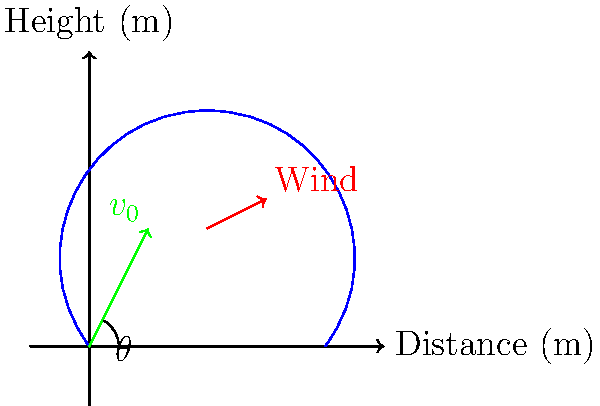As a quarterback, you need to calculate the optimal trajectory for a 40-meter pass. The wind is blowing at 5 m/s at a 30-degree angle to the direction of the pass. Given that the optimal launch angle $\theta$ for a projectile without wind is 45 degrees, calculate the adjusted launch angle to compensate for the wind. Assume the initial velocity of the pass is 25 m/s and neglect air resistance. Round your answer to the nearest degree. To solve this problem, we'll follow these steps:

1) First, we need to understand how wind affects the trajectory. The wind component parallel to the pass direction will affect the range, while the perpendicular component will cause sideways drift.

2) Calculate the wind components:
   Parallel component: $5 \cos(30°) = 4.33$ m/s
   Perpendicular component: $5 \sin(30°) = 2.5$ m/s

3) The parallel wind component effectively changes the initial velocity. The new effective velocity in the direction of the pass is:
   $v_{eff} = 25 - 4.33 = 20.67$ m/s

4) The range of a projectile without wind is given by:
   $R = \frac{v_0^2 \sin(2\theta)}{g}$

5) To maintain the same range of 40 m with the reduced effective velocity, we need to increase the launch angle. Using the range equation:

   $40 = \frac{20.67^2 \sin(2\theta)}{9.8}$

6) Solving for $\theta$:
   $\sin(2\theta) = \frac{40 \cdot 9.8}{20.67^2} = 0.9246$
   $2\theta = \arcsin(0.9246) = 67.6°$
   $\theta = 33.8°$

7) To compensate for the perpendicular wind component, we need to adjust the angle slightly into the wind. The adjustment angle can be approximated as:

   $\Delta\theta = \arctan(\frac{2.5}{20.67}) = 6.9°$

8) The final adjusted angle is:
   $\theta_{adjusted} = 33.8° + 6.9° = 40.7°$

9) Rounding to the nearest degree: 41°
Answer: 41° 